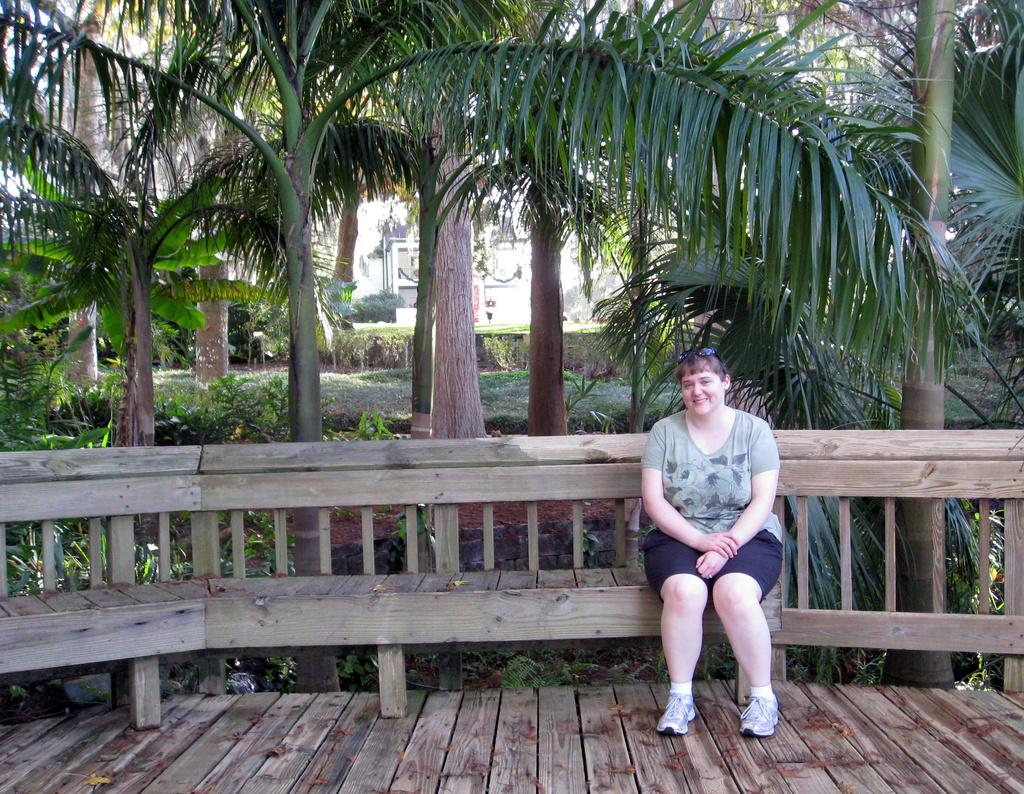What is the woman in the image doing? A: The woman is sitting on a bench in the image. What can be seen in the background of the image? There are buildings, trees, creepers, and the sky visible in the background of the image. What is the ground like in the image? The ground is visible in the image. How does the woman balance the bushes on her neck in the image? There are no bushes or any indication of the woman balancing anything on her neck in the image. 